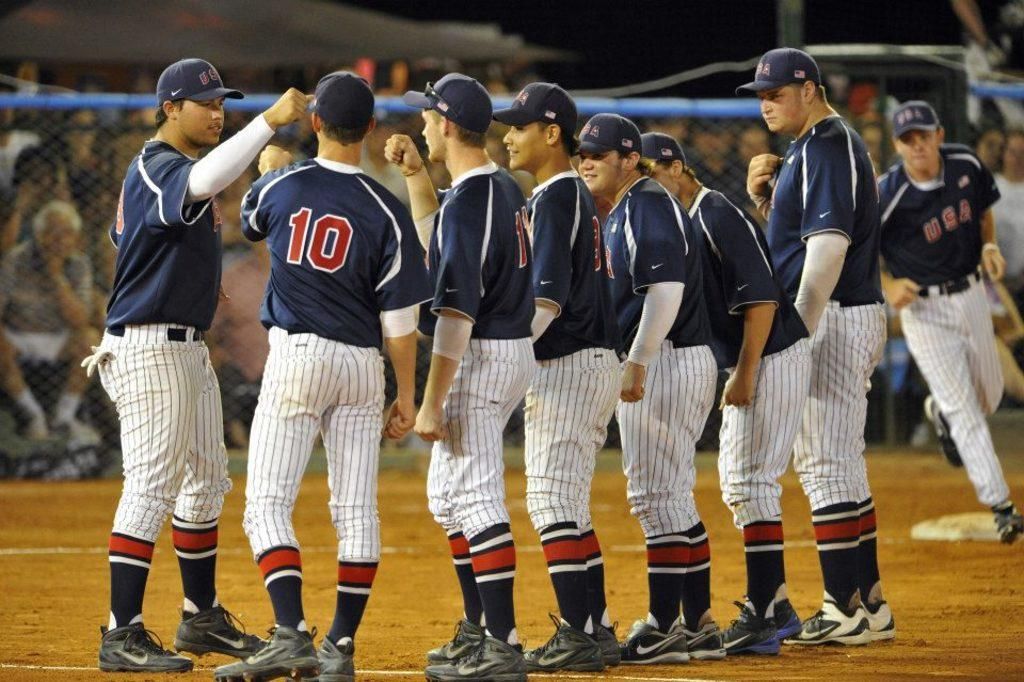<image>
Summarize the visual content of the image. A high school or college baseball team including player 10 are together before a game starts. 